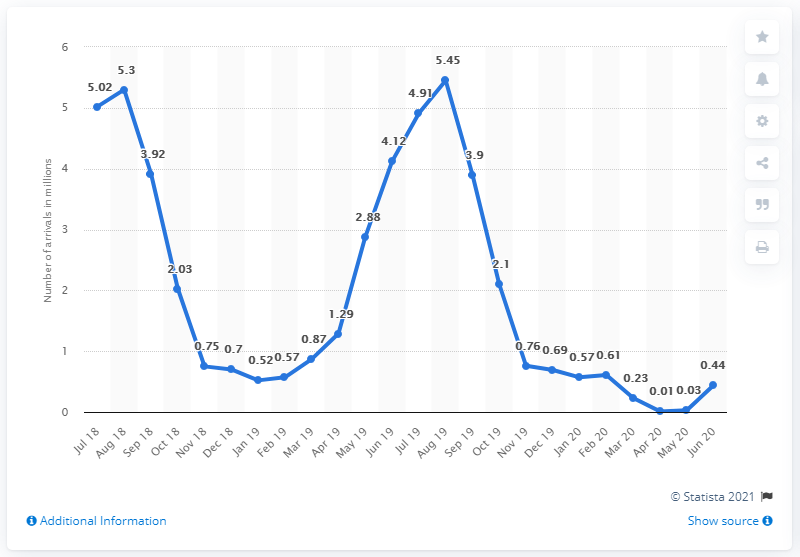Specify some key components in this picture. In June, there were 0.44 tourist arrivals in Greece. 